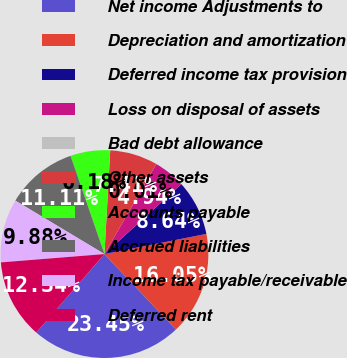Convert chart. <chart><loc_0><loc_0><loc_500><loc_500><pie_chart><fcel>Net income Adjustments to<fcel>Depreciation and amortization<fcel>Deferred income tax provision<fcel>Loss on disposal of assets<fcel>Bad debt allowance<fcel>Other assets<fcel>Accounts payable<fcel>Accrued liabilities<fcel>Income tax payable/receivable<fcel>Deferred rent<nl><fcel>23.45%<fcel>16.05%<fcel>8.64%<fcel>4.94%<fcel>0.01%<fcel>7.41%<fcel>6.18%<fcel>11.11%<fcel>9.88%<fcel>12.34%<nl></chart> 